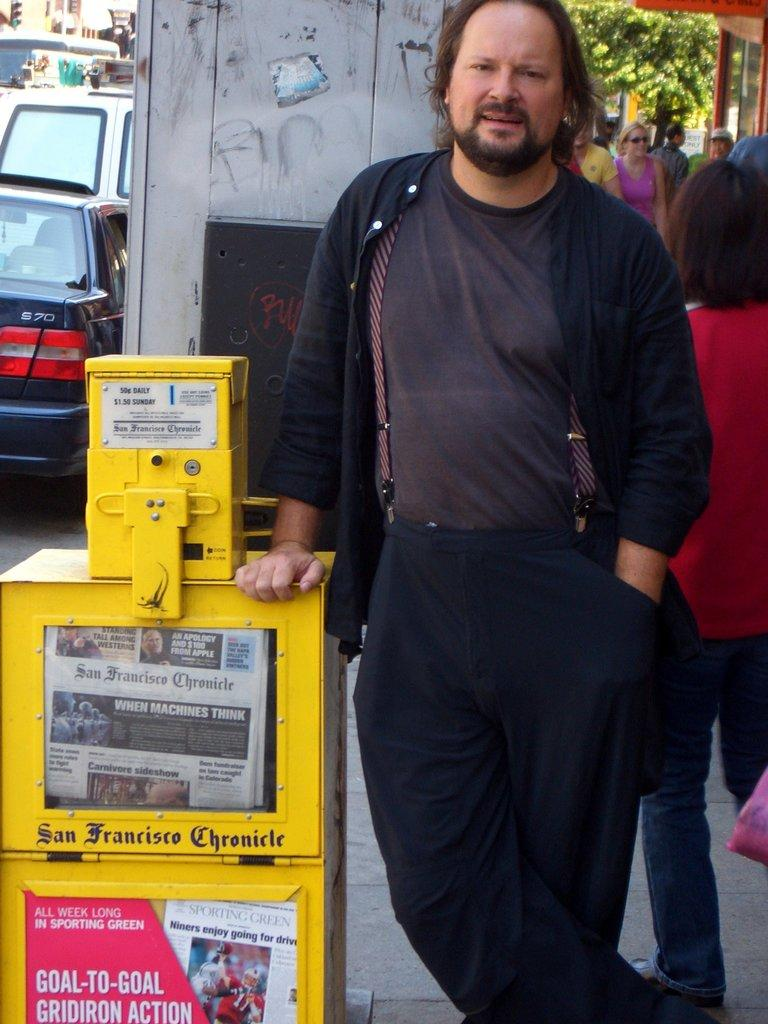Who or what can be seen in the image? There are people in the image. What else is present in the image besides the people? There is a machine, cars in the background, trees in the background, and a building in the image. What type of discussion is taking place between the people and the basket in the image? There is no basket present in the image, and therefore no discussion involving a basket can be observed. 